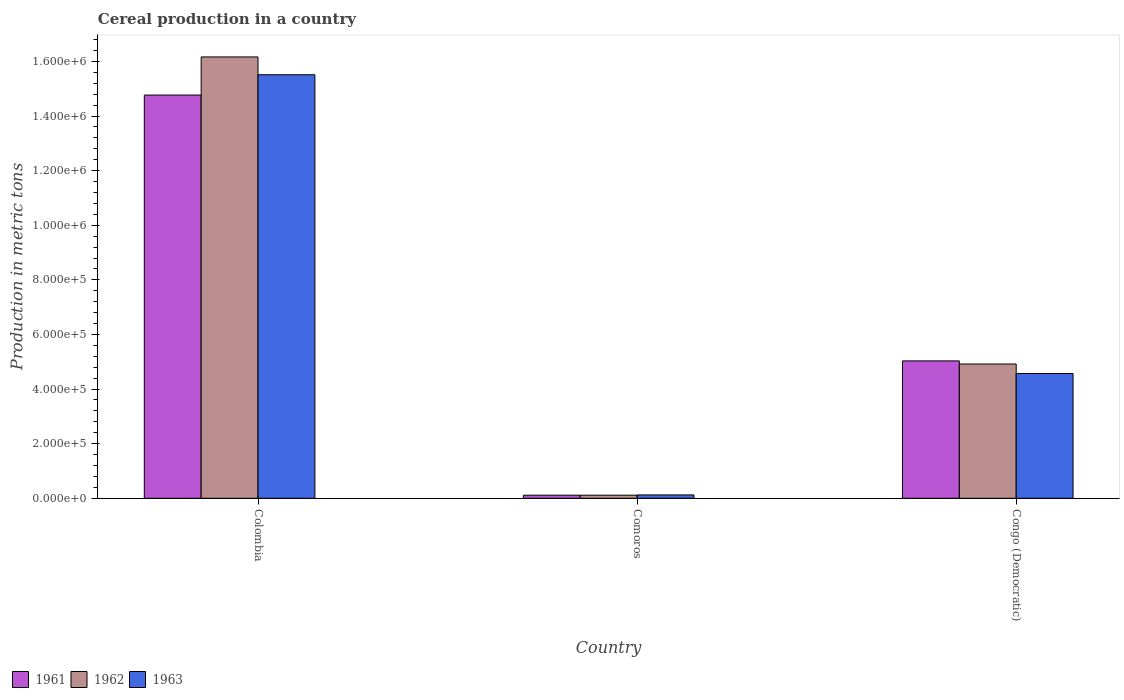How many different coloured bars are there?
Keep it short and to the point. 3. How many groups of bars are there?
Provide a short and direct response. 3. Are the number of bars per tick equal to the number of legend labels?
Your response must be concise. Yes. How many bars are there on the 2nd tick from the right?
Make the answer very short. 3. What is the label of the 2nd group of bars from the left?
Provide a succinct answer. Comoros. What is the total cereal production in 1963 in Comoros?
Give a very brief answer. 1.23e+04. Across all countries, what is the maximum total cereal production in 1961?
Your answer should be compact. 1.48e+06. Across all countries, what is the minimum total cereal production in 1961?
Offer a very short reply. 1.13e+04. In which country was the total cereal production in 1963 minimum?
Provide a short and direct response. Comoros. What is the total total cereal production in 1963 in the graph?
Provide a succinct answer. 2.02e+06. What is the difference between the total cereal production in 1962 in Comoros and that in Congo (Democratic)?
Offer a terse response. -4.80e+05. What is the difference between the total cereal production in 1962 in Comoros and the total cereal production in 1961 in Colombia?
Offer a terse response. -1.47e+06. What is the average total cereal production in 1961 per country?
Your answer should be very brief. 6.64e+05. What is the difference between the total cereal production of/in 1962 and total cereal production of/in 1961 in Comoros?
Offer a very short reply. 0. What is the ratio of the total cereal production in 1962 in Colombia to that in Congo (Democratic)?
Provide a succinct answer. 3.29. What is the difference between the highest and the second highest total cereal production in 1961?
Make the answer very short. 9.74e+05. What is the difference between the highest and the lowest total cereal production in 1962?
Your answer should be compact. 1.61e+06. In how many countries, is the total cereal production in 1962 greater than the average total cereal production in 1962 taken over all countries?
Your answer should be very brief. 1. Is the sum of the total cereal production in 1962 in Colombia and Comoros greater than the maximum total cereal production in 1963 across all countries?
Keep it short and to the point. Yes. What does the 2nd bar from the left in Comoros represents?
Offer a terse response. 1962. Is it the case that in every country, the sum of the total cereal production in 1961 and total cereal production in 1963 is greater than the total cereal production in 1962?
Offer a very short reply. Yes. How many countries are there in the graph?
Offer a terse response. 3. Where does the legend appear in the graph?
Provide a succinct answer. Bottom left. How many legend labels are there?
Keep it short and to the point. 3. How are the legend labels stacked?
Your answer should be very brief. Horizontal. What is the title of the graph?
Make the answer very short. Cereal production in a country. Does "1963" appear as one of the legend labels in the graph?
Your answer should be very brief. Yes. What is the label or title of the X-axis?
Provide a succinct answer. Country. What is the label or title of the Y-axis?
Your response must be concise. Production in metric tons. What is the Production in metric tons of 1961 in Colombia?
Ensure brevity in your answer.  1.48e+06. What is the Production in metric tons in 1962 in Colombia?
Give a very brief answer. 1.62e+06. What is the Production in metric tons in 1963 in Colombia?
Offer a very short reply. 1.55e+06. What is the Production in metric tons in 1961 in Comoros?
Provide a succinct answer. 1.13e+04. What is the Production in metric tons in 1962 in Comoros?
Keep it short and to the point. 1.13e+04. What is the Production in metric tons in 1963 in Comoros?
Provide a succinct answer. 1.23e+04. What is the Production in metric tons in 1961 in Congo (Democratic)?
Ensure brevity in your answer.  5.03e+05. What is the Production in metric tons of 1962 in Congo (Democratic)?
Your answer should be very brief. 4.92e+05. What is the Production in metric tons of 1963 in Congo (Democratic)?
Offer a very short reply. 4.57e+05. Across all countries, what is the maximum Production in metric tons in 1961?
Keep it short and to the point. 1.48e+06. Across all countries, what is the maximum Production in metric tons of 1962?
Provide a succinct answer. 1.62e+06. Across all countries, what is the maximum Production in metric tons in 1963?
Your response must be concise. 1.55e+06. Across all countries, what is the minimum Production in metric tons of 1961?
Make the answer very short. 1.13e+04. Across all countries, what is the minimum Production in metric tons of 1962?
Your answer should be compact. 1.13e+04. Across all countries, what is the minimum Production in metric tons in 1963?
Make the answer very short. 1.23e+04. What is the total Production in metric tons in 1961 in the graph?
Your response must be concise. 1.99e+06. What is the total Production in metric tons in 1962 in the graph?
Keep it short and to the point. 2.12e+06. What is the total Production in metric tons in 1963 in the graph?
Make the answer very short. 2.02e+06. What is the difference between the Production in metric tons of 1961 in Colombia and that in Comoros?
Ensure brevity in your answer.  1.47e+06. What is the difference between the Production in metric tons in 1962 in Colombia and that in Comoros?
Make the answer very short. 1.61e+06. What is the difference between the Production in metric tons of 1963 in Colombia and that in Comoros?
Provide a succinct answer. 1.54e+06. What is the difference between the Production in metric tons in 1961 in Colombia and that in Congo (Democratic)?
Provide a succinct answer. 9.74e+05. What is the difference between the Production in metric tons of 1962 in Colombia and that in Congo (Democratic)?
Offer a very short reply. 1.12e+06. What is the difference between the Production in metric tons in 1963 in Colombia and that in Congo (Democratic)?
Your response must be concise. 1.09e+06. What is the difference between the Production in metric tons in 1961 in Comoros and that in Congo (Democratic)?
Offer a very short reply. -4.92e+05. What is the difference between the Production in metric tons of 1962 in Comoros and that in Congo (Democratic)?
Offer a terse response. -4.80e+05. What is the difference between the Production in metric tons in 1963 in Comoros and that in Congo (Democratic)?
Provide a succinct answer. -4.45e+05. What is the difference between the Production in metric tons in 1961 in Colombia and the Production in metric tons in 1962 in Comoros?
Keep it short and to the point. 1.47e+06. What is the difference between the Production in metric tons of 1961 in Colombia and the Production in metric tons of 1963 in Comoros?
Offer a very short reply. 1.46e+06. What is the difference between the Production in metric tons in 1962 in Colombia and the Production in metric tons in 1963 in Comoros?
Provide a short and direct response. 1.60e+06. What is the difference between the Production in metric tons in 1961 in Colombia and the Production in metric tons in 1962 in Congo (Democratic)?
Make the answer very short. 9.85e+05. What is the difference between the Production in metric tons of 1961 in Colombia and the Production in metric tons of 1963 in Congo (Democratic)?
Your response must be concise. 1.02e+06. What is the difference between the Production in metric tons of 1962 in Colombia and the Production in metric tons of 1963 in Congo (Democratic)?
Provide a succinct answer. 1.16e+06. What is the difference between the Production in metric tons in 1961 in Comoros and the Production in metric tons in 1962 in Congo (Democratic)?
Offer a very short reply. -4.80e+05. What is the difference between the Production in metric tons of 1961 in Comoros and the Production in metric tons of 1963 in Congo (Democratic)?
Your answer should be compact. -4.46e+05. What is the difference between the Production in metric tons of 1962 in Comoros and the Production in metric tons of 1963 in Congo (Democratic)?
Provide a short and direct response. -4.46e+05. What is the average Production in metric tons in 1961 per country?
Provide a short and direct response. 6.64e+05. What is the average Production in metric tons of 1962 per country?
Ensure brevity in your answer.  7.07e+05. What is the average Production in metric tons of 1963 per country?
Your answer should be very brief. 6.74e+05. What is the difference between the Production in metric tons of 1961 and Production in metric tons of 1962 in Colombia?
Keep it short and to the point. -1.40e+05. What is the difference between the Production in metric tons in 1961 and Production in metric tons in 1963 in Colombia?
Give a very brief answer. -7.44e+04. What is the difference between the Production in metric tons in 1962 and Production in metric tons in 1963 in Colombia?
Offer a very short reply. 6.52e+04. What is the difference between the Production in metric tons of 1961 and Production in metric tons of 1963 in Comoros?
Your response must be concise. -1000. What is the difference between the Production in metric tons in 1962 and Production in metric tons in 1963 in Comoros?
Ensure brevity in your answer.  -1000. What is the difference between the Production in metric tons in 1961 and Production in metric tons in 1962 in Congo (Democratic)?
Provide a succinct answer. 1.14e+04. What is the difference between the Production in metric tons of 1961 and Production in metric tons of 1963 in Congo (Democratic)?
Your answer should be compact. 4.63e+04. What is the difference between the Production in metric tons in 1962 and Production in metric tons in 1963 in Congo (Democratic)?
Your response must be concise. 3.48e+04. What is the ratio of the Production in metric tons of 1961 in Colombia to that in Comoros?
Your answer should be very brief. 130.7. What is the ratio of the Production in metric tons of 1962 in Colombia to that in Comoros?
Ensure brevity in your answer.  143.05. What is the ratio of the Production in metric tons in 1963 in Colombia to that in Comoros?
Make the answer very short. 126.12. What is the ratio of the Production in metric tons in 1961 in Colombia to that in Congo (Democratic)?
Ensure brevity in your answer.  2.94. What is the ratio of the Production in metric tons of 1962 in Colombia to that in Congo (Democratic)?
Offer a terse response. 3.29. What is the ratio of the Production in metric tons of 1963 in Colombia to that in Congo (Democratic)?
Provide a succinct answer. 3.39. What is the ratio of the Production in metric tons of 1961 in Comoros to that in Congo (Democratic)?
Keep it short and to the point. 0.02. What is the ratio of the Production in metric tons in 1962 in Comoros to that in Congo (Democratic)?
Your answer should be compact. 0.02. What is the ratio of the Production in metric tons in 1963 in Comoros to that in Congo (Democratic)?
Offer a very short reply. 0.03. What is the difference between the highest and the second highest Production in metric tons of 1961?
Provide a short and direct response. 9.74e+05. What is the difference between the highest and the second highest Production in metric tons of 1962?
Your answer should be compact. 1.12e+06. What is the difference between the highest and the second highest Production in metric tons in 1963?
Keep it short and to the point. 1.09e+06. What is the difference between the highest and the lowest Production in metric tons in 1961?
Offer a very short reply. 1.47e+06. What is the difference between the highest and the lowest Production in metric tons of 1962?
Make the answer very short. 1.61e+06. What is the difference between the highest and the lowest Production in metric tons of 1963?
Offer a terse response. 1.54e+06. 